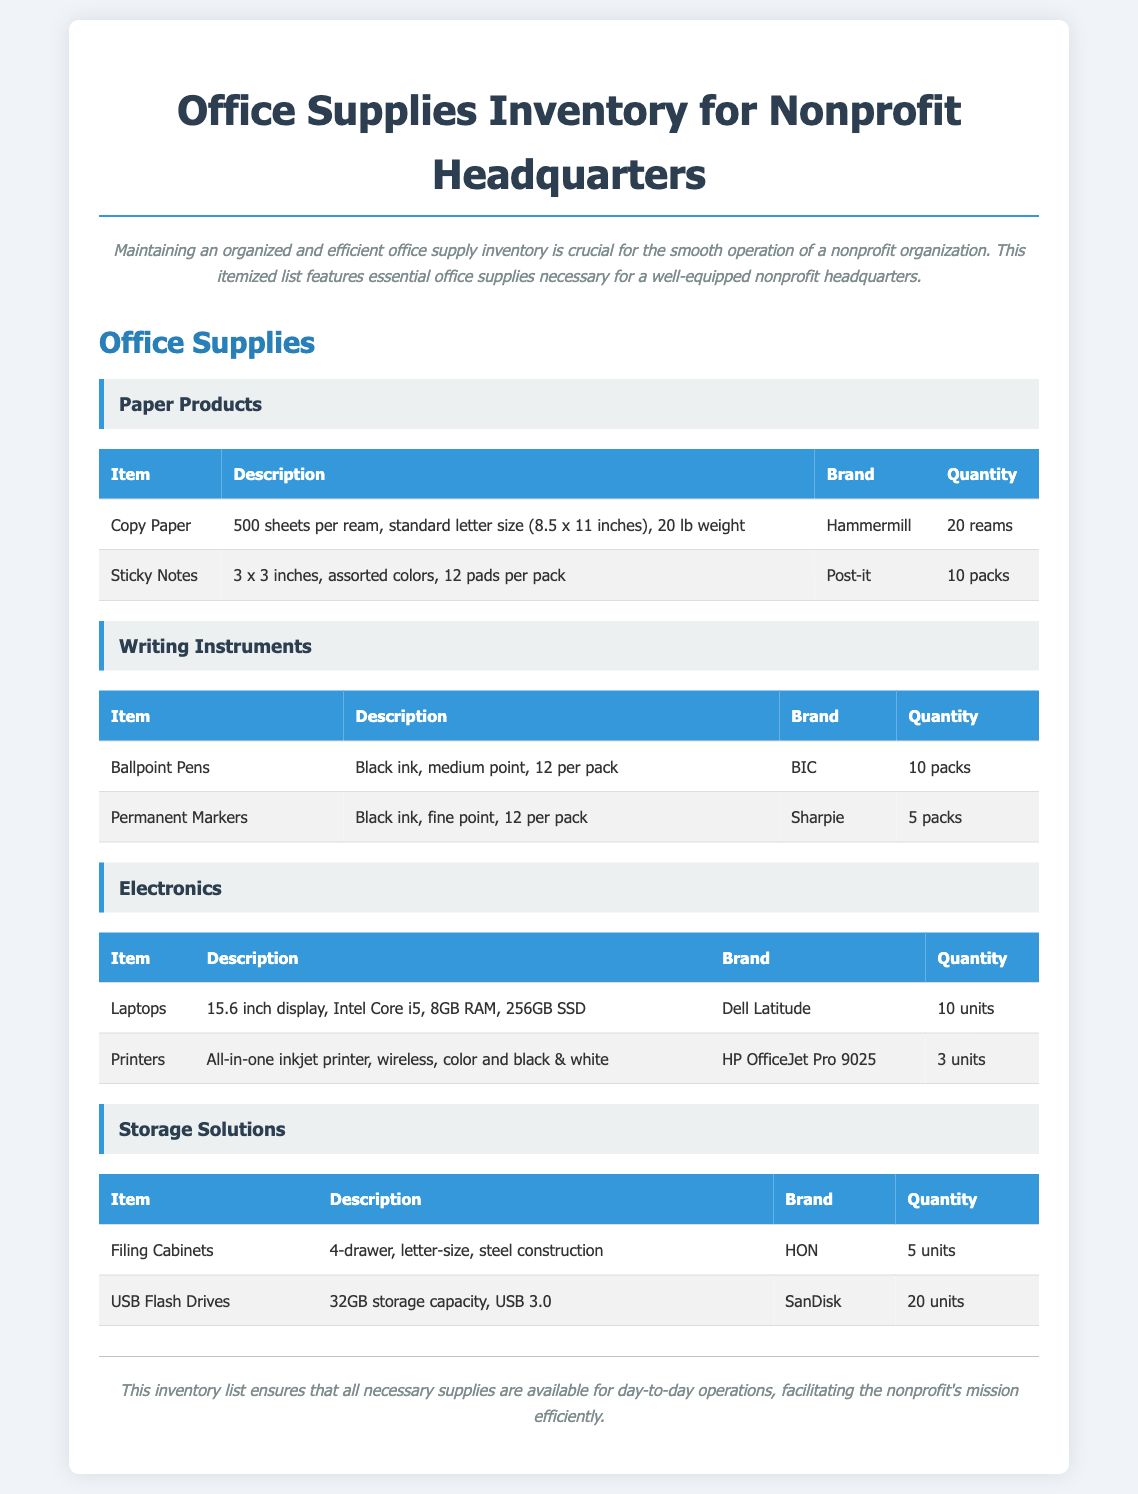What brand of paper is listed first? The first paper product is Copy Paper, and its brand is Hammermill.
Answer: Hammermill How many reams of copy paper are included? The inventory specifies 20 reams of copy paper.
Answer: 20 reams What is the quantity of laptops listed? The document states there are 10 units of laptops available.
Answer: 10 units What type of filing cabinets are included? The filing cabinets are 4-drawer, letter-size, and made of steel.
Answer: 4-drawer How many packs of permanent markers are included? The inventory indicates there are 5 packs of permanent markers under writing instruments.
Answer: 5 packs Which brand of printers is mentioned in the inventory? The brand for printers listed is HP.
Answer: HP What is the total number of USB flash drives? The document states a total of 20 units of USB flash drives are present.
Answer: 20 units How many packs of sticky notes are listed? The inventory specifies there are 10 packs of sticky notes.
Answer: 10 packs What is the storage capacity of the USB flash drives? The USB flash drives listed have a storage capacity of 32GB.
Answer: 32GB 